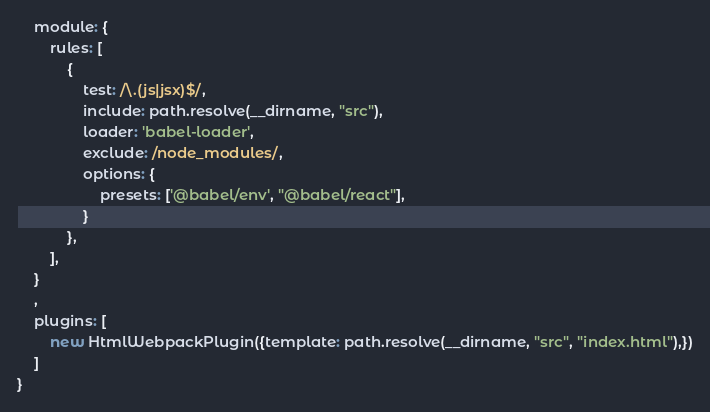<code> <loc_0><loc_0><loc_500><loc_500><_JavaScript_>    module: {
        rules: [
            {
                test: /\.(js|jsx)$/,
                include: path.resolve(__dirname, "src"),
                loader: 'babel-loader',
                exclude: /node_modules/,
                options: {
                    presets: ['@babel/env', "@babel/react"],
                }
            },
        ],
    }
    ,
    plugins: [
        new HtmlWebpackPlugin({template: path.resolve(__dirname, "src", "index.html"),})
    ]
}</code> 